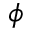Convert formula to latex. <formula><loc_0><loc_0><loc_500><loc_500>\phi</formula> 